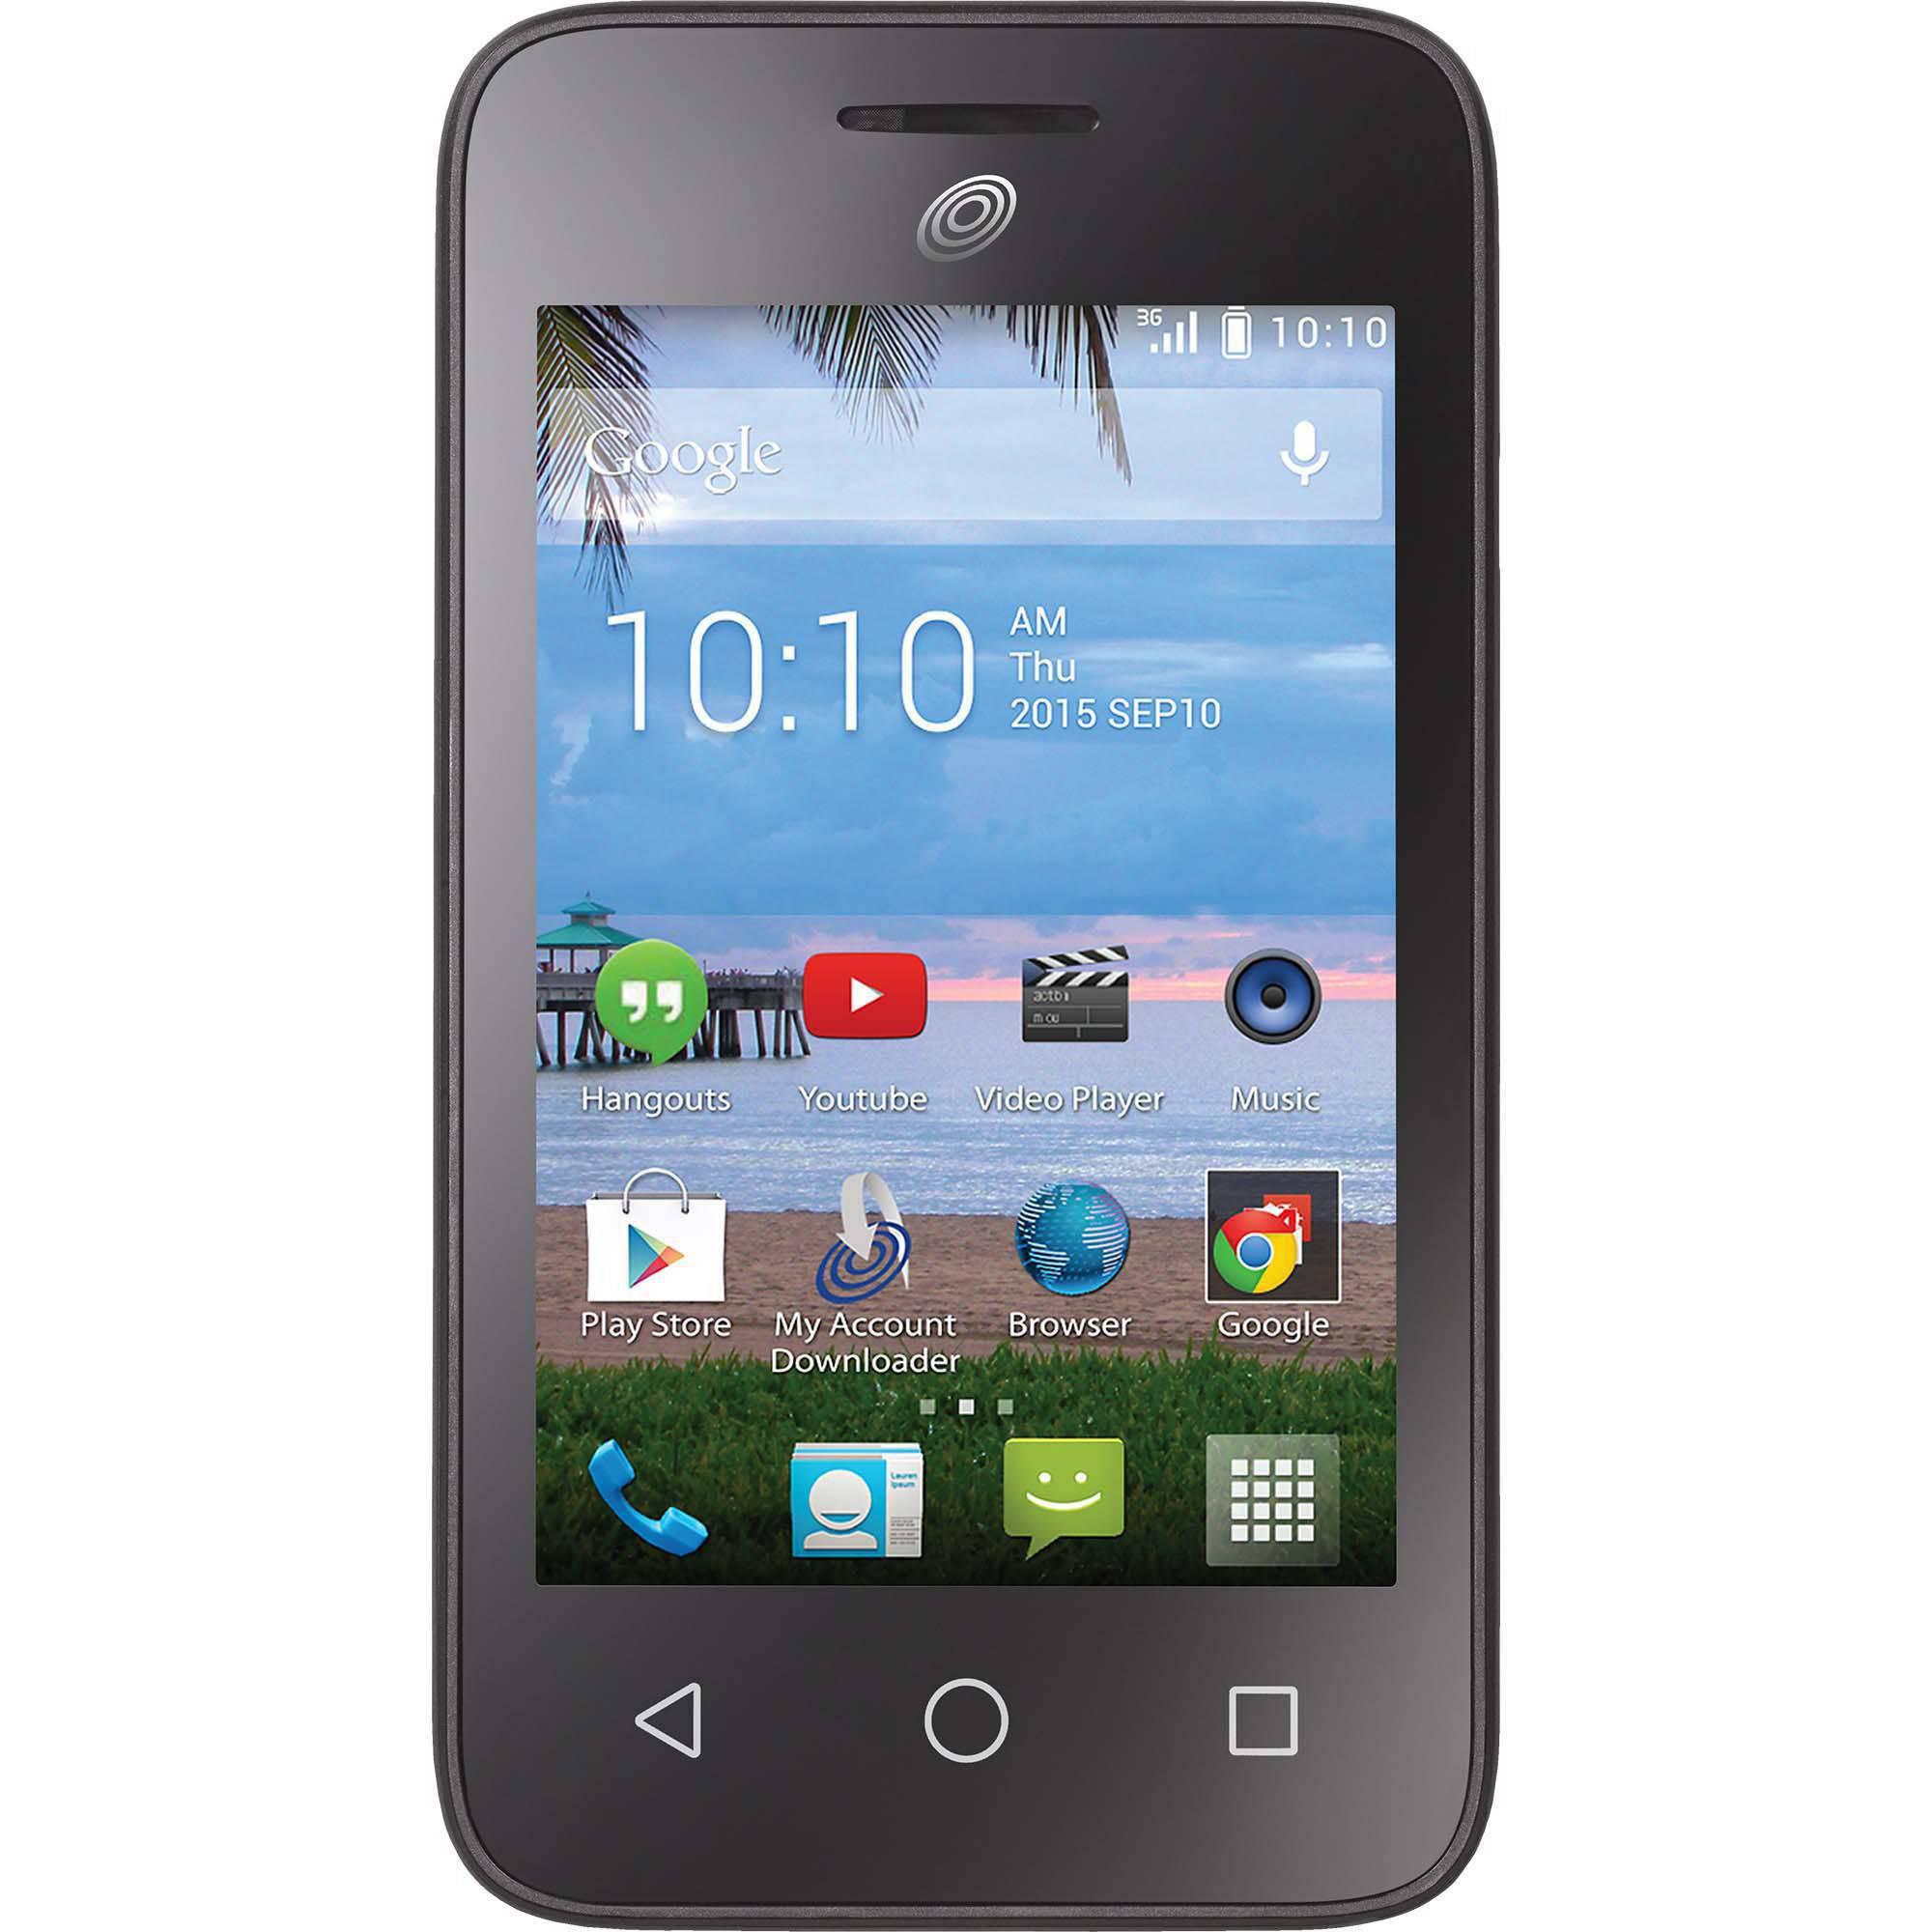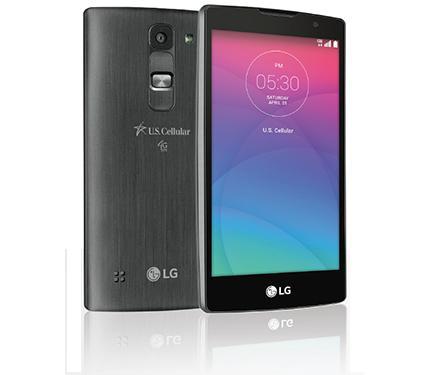The first image is the image on the left, the second image is the image on the right. Analyze the images presented: Is the assertion "The phone on the left has a beach wallpaper, the phone on the right has an abstract wallpaper." valid? Answer yes or no. Yes. 